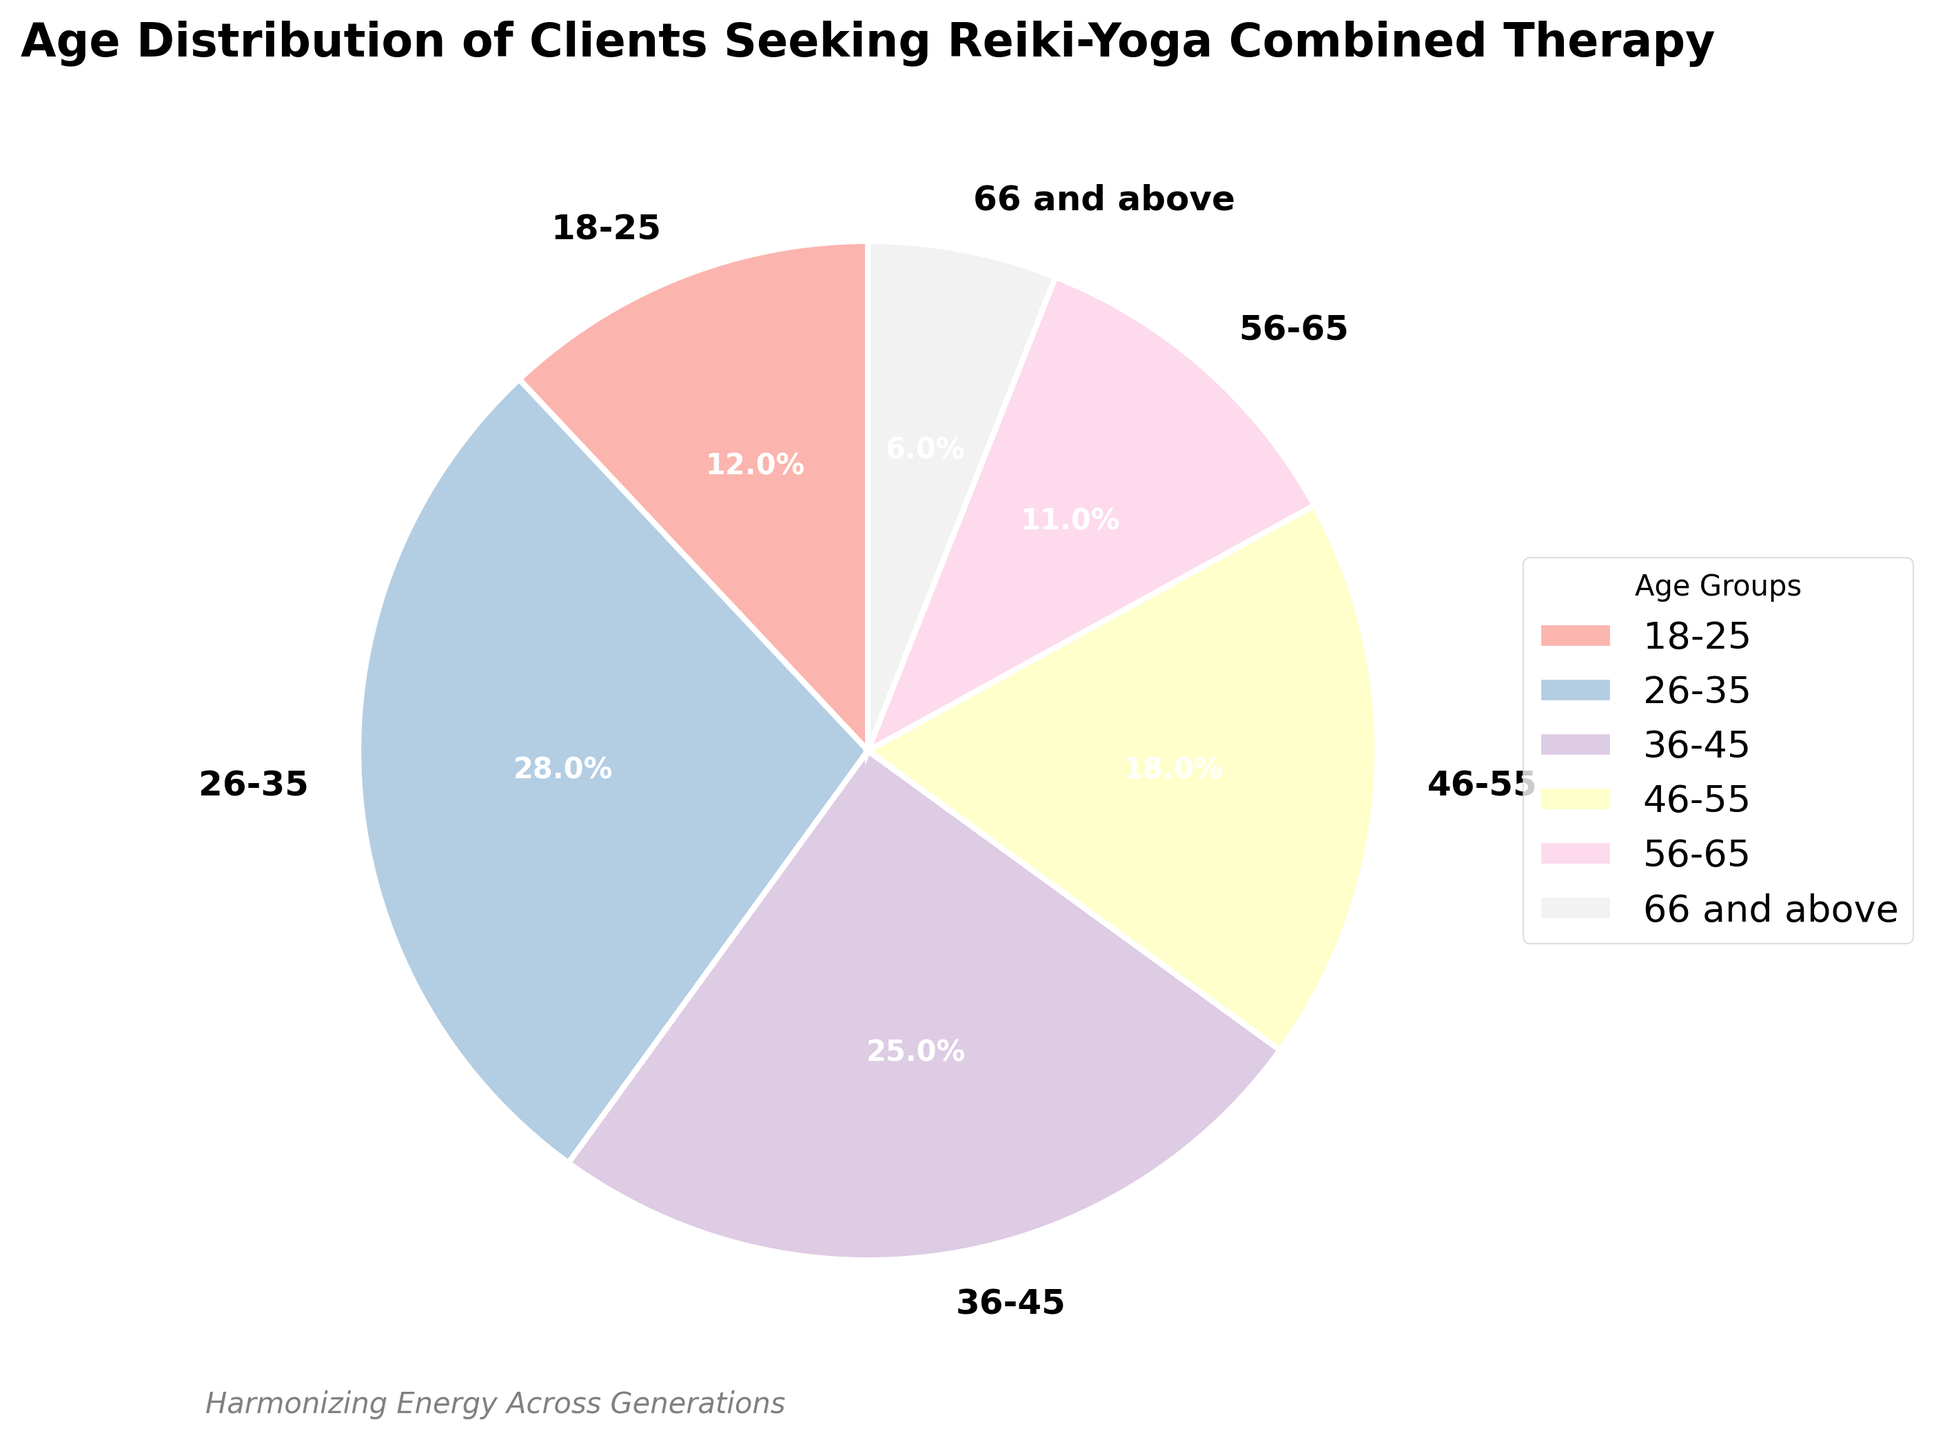What is the most common age group among clients seeking Reiki-Yoga combined therapy? The figure shows various age groups with their percentages. The age group 26-35 has the highest percentage at 28%.
Answer: Age group 26-35 What is the combined percentage of clients older than 45 seeking this therapy? The figure indicates the percentages of clients in the age groups 46-55 (18%), 56-65 (11%), and 66 and above (6%). Adding these percentages gives 18% + 11% + 6% = 35%.
Answer: 35% Which age group has the smallest proportion of clients seeking the therapy? By looking at the figure, the age group 66 and above has the smallest percentage at 6%.
Answer: Age group 66 and above How does the percentage of the 36-45 age group compare to the 46-55 age group? The figure shows the percentage for the 36-45 age group is 25%, while for the 46-55 age group, it is 18%. Therefore, the 36-45 age group has a higher percentage.
Answer: 36-45 age group has a higher percentage What is the total percentage of clients aged 35 or younger seeking the therapy? The relevant age groups are 18-25 (12%) and 26-35 (28%). Adding these percentages gives 12% + 28% = 40%.
Answer: 40% Which two age groups together make up nearly half of the clients? Combining the percentages of age groups 26-35 (28%) and 36-45 (25%) gives 28% + 25% = 53%, which is close to half (50%).
Answer: 26-35 and 36-45 How much more common is the 26-35 age group compared to the 56-65 age group? The 26-35 age group is 28%, and the 56-65 age group is 11%. The difference is 28% - 11% = 17%.
Answer: 17% more common What is the visual color of the age group with the least percentage? The least percentage is 6% for the age group 66 and above, which should be represented by the last color in the pastel color scheme used in the pie chart.
Answer: Light color Are there any labels showing the percentage values directly on the pie chart slices? Observing the pie chart, each slice has a label displaying the percentage it represents.
Answer: Yes What fraction of the clients fall between the ages of 18 and 45? The age groups 18-25 (12%), 26-35 (28%), and 36-45 (25%) sum to 12% + 28% + 25% = 65%. Therefore, the fraction is 65%.
Answer: 65% 